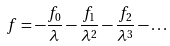Convert formula to latex. <formula><loc_0><loc_0><loc_500><loc_500>f = - \frac { f _ { 0 } } { \lambda } - \frac { f _ { 1 } } { \lambda ^ { 2 } } - \frac { f _ { 2 } } { \lambda ^ { 3 } } - \dots</formula> 